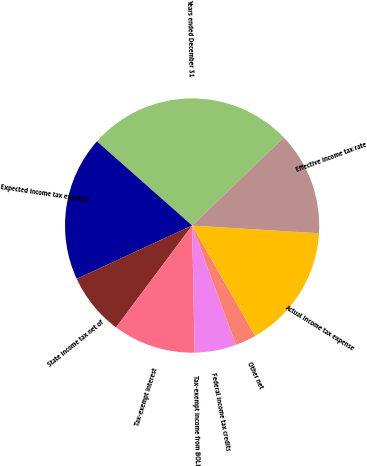Convert chart. <chart><loc_0><loc_0><loc_500><loc_500><pie_chart><fcel>Years ended December 31<fcel>Expected income tax expense<fcel>State income tax net of<fcel>Tax-exempt interest<fcel>Tax-exempt income from BOLI<fcel>Federal income tax credits<fcel>Other net<fcel>Actual income tax expense<fcel>Effective income tax rate<nl><fcel>26.29%<fcel>18.41%<fcel>7.9%<fcel>10.53%<fcel>0.02%<fcel>5.27%<fcel>2.65%<fcel>15.78%<fcel>13.15%<nl></chart> 